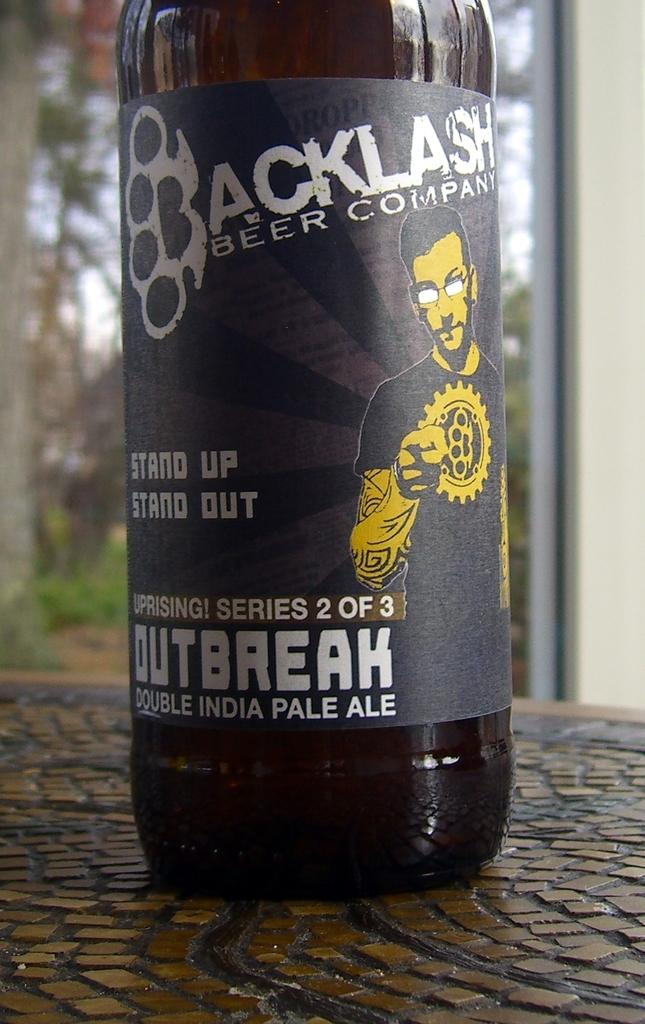<image>
Render a clear and concise summary of the photo. Uprising! Series 2 out of 3 bottle of Outbreak double India pale ale sitting on a table. 